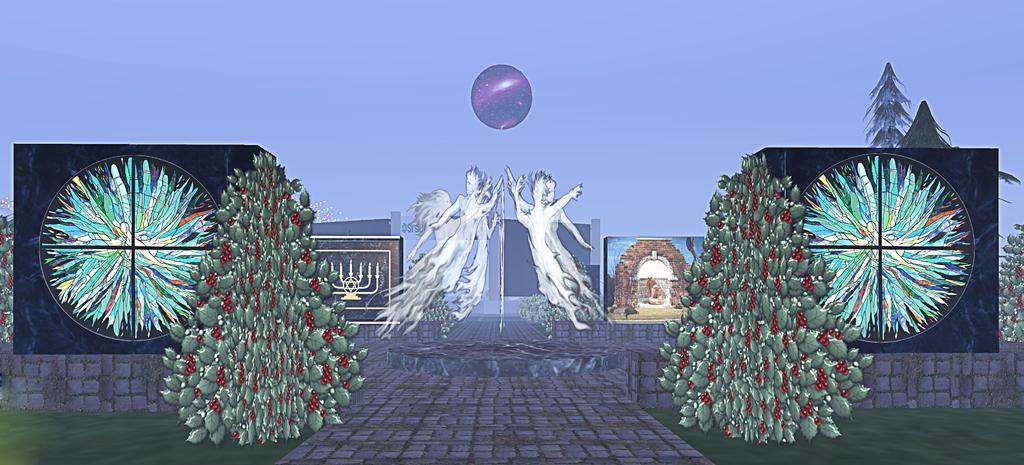How would you summarize this image in a sentence or two? Here this picture is an animated image and in the middle of it we can see angels flying in the air and we can see plants and trees present here and there and on either side we can see some picture designs present and we can see the ground is covered with grass over there and in the middle we can see moon present in the sky. 